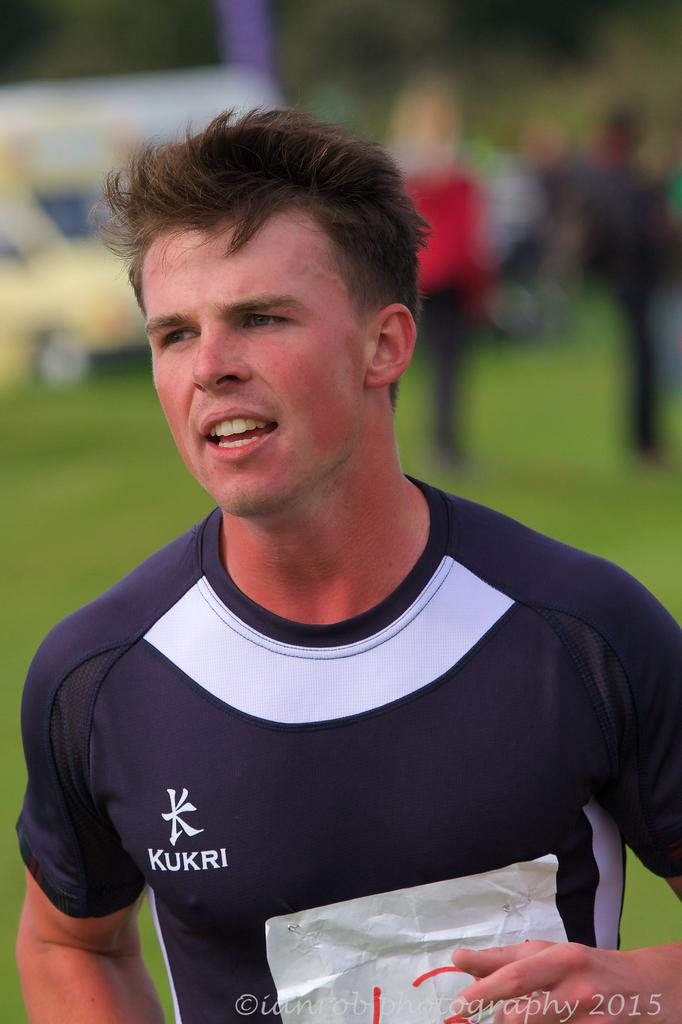<image>
Write a terse but informative summary of the picture. A guy is wearing a blue shirt with a KUKRI logo on it. 